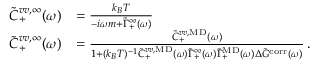<formula> <loc_0><loc_0><loc_500><loc_500>\begin{array} { r l } { \tilde { C } _ { + } ^ { v v , \infty } ( \omega ) } & { = \frac { k _ { B } T } { - i \omega m + \tilde { \Gamma } _ { + } ^ { \infty } ( \omega ) } } \\ { \tilde { C } _ { + } ^ { v v , \infty } ( \omega ) } & { = \frac { \tilde { C } _ { + } ^ { v v , M D } ( \omega ) } { 1 + ( k _ { B } T ) ^ { - 1 } \tilde { C } _ { + } ^ { v v , M D } ( \omega ) \tilde { \Gamma } _ { + } ^ { \infty } ( \omega ) \tilde { \Gamma } _ { + } ^ { M D } ( \omega ) \Delta \tilde { G } ^ { c o r r } ( \omega ) } \, . } \end{array}</formula> 